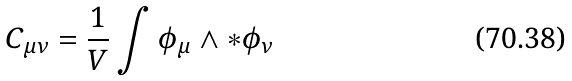Convert formula to latex. <formula><loc_0><loc_0><loc_500><loc_500>C _ { \mu \nu } = \frac { 1 } { V } \int \phi _ { \mu } \wedge \ast \phi _ { \nu }</formula> 